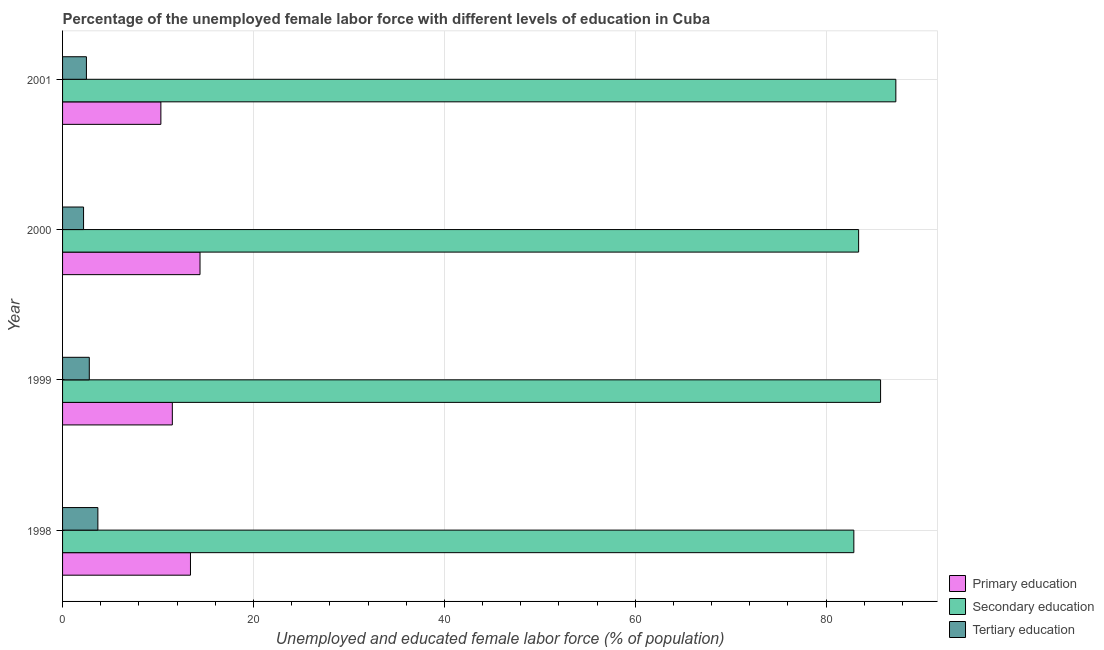How many different coloured bars are there?
Your answer should be very brief. 3. How many groups of bars are there?
Give a very brief answer. 4. How many bars are there on the 2nd tick from the top?
Make the answer very short. 3. In how many cases, is the number of bars for a given year not equal to the number of legend labels?
Your response must be concise. 0. What is the percentage of female labor force who received secondary education in 2001?
Your answer should be compact. 87.3. Across all years, what is the maximum percentage of female labor force who received tertiary education?
Offer a very short reply. 3.7. Across all years, what is the minimum percentage of female labor force who received primary education?
Offer a terse response. 10.3. In which year was the percentage of female labor force who received primary education maximum?
Make the answer very short. 2000. What is the total percentage of female labor force who received secondary education in the graph?
Your answer should be compact. 339.3. What is the difference between the percentage of female labor force who received secondary education in 1998 and that in 2001?
Provide a short and direct response. -4.4. What is the difference between the percentage of female labor force who received primary education in 2001 and the percentage of female labor force who received tertiary education in 1998?
Offer a very short reply. 6.6. In the year 1999, what is the difference between the percentage of female labor force who received tertiary education and percentage of female labor force who received primary education?
Give a very brief answer. -8.7. Is the percentage of female labor force who received tertiary education in 1998 less than that in 2001?
Keep it short and to the point. No. In how many years, is the percentage of female labor force who received secondary education greater than the average percentage of female labor force who received secondary education taken over all years?
Keep it short and to the point. 2. What does the 2nd bar from the top in 2001 represents?
Provide a short and direct response. Secondary education. What does the 3rd bar from the bottom in 2001 represents?
Provide a succinct answer. Tertiary education. Is it the case that in every year, the sum of the percentage of female labor force who received primary education and percentage of female labor force who received secondary education is greater than the percentage of female labor force who received tertiary education?
Your response must be concise. Yes. Are the values on the major ticks of X-axis written in scientific E-notation?
Offer a terse response. No. Does the graph contain grids?
Provide a short and direct response. Yes. Where does the legend appear in the graph?
Give a very brief answer. Bottom right. How are the legend labels stacked?
Your answer should be very brief. Vertical. What is the title of the graph?
Keep it short and to the point. Percentage of the unemployed female labor force with different levels of education in Cuba. What is the label or title of the X-axis?
Offer a very short reply. Unemployed and educated female labor force (% of population). What is the label or title of the Y-axis?
Provide a short and direct response. Year. What is the Unemployed and educated female labor force (% of population) in Primary education in 1998?
Offer a terse response. 13.4. What is the Unemployed and educated female labor force (% of population) in Secondary education in 1998?
Provide a short and direct response. 82.9. What is the Unemployed and educated female labor force (% of population) of Tertiary education in 1998?
Your answer should be compact. 3.7. What is the Unemployed and educated female labor force (% of population) of Secondary education in 1999?
Offer a very short reply. 85.7. What is the Unemployed and educated female labor force (% of population) of Tertiary education in 1999?
Offer a terse response. 2.8. What is the Unemployed and educated female labor force (% of population) in Primary education in 2000?
Your answer should be compact. 14.4. What is the Unemployed and educated female labor force (% of population) of Secondary education in 2000?
Ensure brevity in your answer.  83.4. What is the Unemployed and educated female labor force (% of population) in Tertiary education in 2000?
Make the answer very short. 2.2. What is the Unemployed and educated female labor force (% of population) in Primary education in 2001?
Provide a short and direct response. 10.3. What is the Unemployed and educated female labor force (% of population) of Secondary education in 2001?
Offer a terse response. 87.3. What is the Unemployed and educated female labor force (% of population) in Tertiary education in 2001?
Keep it short and to the point. 2.5. Across all years, what is the maximum Unemployed and educated female labor force (% of population) of Primary education?
Your response must be concise. 14.4. Across all years, what is the maximum Unemployed and educated female labor force (% of population) in Secondary education?
Give a very brief answer. 87.3. Across all years, what is the maximum Unemployed and educated female labor force (% of population) of Tertiary education?
Make the answer very short. 3.7. Across all years, what is the minimum Unemployed and educated female labor force (% of population) of Primary education?
Provide a succinct answer. 10.3. Across all years, what is the minimum Unemployed and educated female labor force (% of population) of Secondary education?
Offer a terse response. 82.9. Across all years, what is the minimum Unemployed and educated female labor force (% of population) in Tertiary education?
Keep it short and to the point. 2.2. What is the total Unemployed and educated female labor force (% of population) of Primary education in the graph?
Your response must be concise. 49.6. What is the total Unemployed and educated female labor force (% of population) in Secondary education in the graph?
Provide a short and direct response. 339.3. What is the total Unemployed and educated female labor force (% of population) in Tertiary education in the graph?
Provide a succinct answer. 11.2. What is the difference between the Unemployed and educated female labor force (% of population) in Tertiary education in 1998 and that in 1999?
Give a very brief answer. 0.9. What is the difference between the Unemployed and educated female labor force (% of population) of Primary education in 1998 and that in 2000?
Provide a short and direct response. -1. What is the difference between the Unemployed and educated female labor force (% of population) in Secondary education in 1998 and that in 2000?
Provide a short and direct response. -0.5. What is the difference between the Unemployed and educated female labor force (% of population) in Tertiary education in 1998 and that in 2000?
Offer a terse response. 1.5. What is the difference between the Unemployed and educated female labor force (% of population) in Secondary education in 1998 and that in 2001?
Your answer should be compact. -4.4. What is the difference between the Unemployed and educated female labor force (% of population) of Secondary education in 1999 and that in 2000?
Your answer should be very brief. 2.3. What is the difference between the Unemployed and educated female labor force (% of population) of Tertiary education in 1999 and that in 2000?
Offer a terse response. 0.6. What is the difference between the Unemployed and educated female labor force (% of population) in Secondary education in 1999 and that in 2001?
Provide a short and direct response. -1.6. What is the difference between the Unemployed and educated female labor force (% of population) in Primary education in 2000 and that in 2001?
Your response must be concise. 4.1. What is the difference between the Unemployed and educated female labor force (% of population) of Tertiary education in 2000 and that in 2001?
Your response must be concise. -0.3. What is the difference between the Unemployed and educated female labor force (% of population) in Primary education in 1998 and the Unemployed and educated female labor force (% of population) in Secondary education in 1999?
Offer a very short reply. -72.3. What is the difference between the Unemployed and educated female labor force (% of population) of Secondary education in 1998 and the Unemployed and educated female labor force (% of population) of Tertiary education in 1999?
Make the answer very short. 80.1. What is the difference between the Unemployed and educated female labor force (% of population) of Primary education in 1998 and the Unemployed and educated female labor force (% of population) of Secondary education in 2000?
Your response must be concise. -70. What is the difference between the Unemployed and educated female labor force (% of population) of Secondary education in 1998 and the Unemployed and educated female labor force (% of population) of Tertiary education in 2000?
Provide a short and direct response. 80.7. What is the difference between the Unemployed and educated female labor force (% of population) of Primary education in 1998 and the Unemployed and educated female labor force (% of population) of Secondary education in 2001?
Your response must be concise. -73.9. What is the difference between the Unemployed and educated female labor force (% of population) of Secondary education in 1998 and the Unemployed and educated female labor force (% of population) of Tertiary education in 2001?
Your answer should be very brief. 80.4. What is the difference between the Unemployed and educated female labor force (% of population) of Primary education in 1999 and the Unemployed and educated female labor force (% of population) of Secondary education in 2000?
Ensure brevity in your answer.  -71.9. What is the difference between the Unemployed and educated female labor force (% of population) of Primary education in 1999 and the Unemployed and educated female labor force (% of population) of Tertiary education in 2000?
Your answer should be compact. 9.3. What is the difference between the Unemployed and educated female labor force (% of population) of Secondary education in 1999 and the Unemployed and educated female labor force (% of population) of Tertiary education in 2000?
Your answer should be very brief. 83.5. What is the difference between the Unemployed and educated female labor force (% of population) of Primary education in 1999 and the Unemployed and educated female labor force (% of population) of Secondary education in 2001?
Keep it short and to the point. -75.8. What is the difference between the Unemployed and educated female labor force (% of population) of Primary education in 1999 and the Unemployed and educated female labor force (% of population) of Tertiary education in 2001?
Your answer should be compact. 9. What is the difference between the Unemployed and educated female labor force (% of population) of Secondary education in 1999 and the Unemployed and educated female labor force (% of population) of Tertiary education in 2001?
Your response must be concise. 83.2. What is the difference between the Unemployed and educated female labor force (% of population) of Primary education in 2000 and the Unemployed and educated female labor force (% of population) of Secondary education in 2001?
Provide a succinct answer. -72.9. What is the difference between the Unemployed and educated female labor force (% of population) of Secondary education in 2000 and the Unemployed and educated female labor force (% of population) of Tertiary education in 2001?
Offer a very short reply. 80.9. What is the average Unemployed and educated female labor force (% of population) in Primary education per year?
Offer a very short reply. 12.4. What is the average Unemployed and educated female labor force (% of population) of Secondary education per year?
Give a very brief answer. 84.83. In the year 1998, what is the difference between the Unemployed and educated female labor force (% of population) of Primary education and Unemployed and educated female labor force (% of population) of Secondary education?
Make the answer very short. -69.5. In the year 1998, what is the difference between the Unemployed and educated female labor force (% of population) of Primary education and Unemployed and educated female labor force (% of population) of Tertiary education?
Your response must be concise. 9.7. In the year 1998, what is the difference between the Unemployed and educated female labor force (% of population) of Secondary education and Unemployed and educated female labor force (% of population) of Tertiary education?
Give a very brief answer. 79.2. In the year 1999, what is the difference between the Unemployed and educated female labor force (% of population) in Primary education and Unemployed and educated female labor force (% of population) in Secondary education?
Offer a terse response. -74.2. In the year 1999, what is the difference between the Unemployed and educated female labor force (% of population) of Secondary education and Unemployed and educated female labor force (% of population) of Tertiary education?
Ensure brevity in your answer.  82.9. In the year 2000, what is the difference between the Unemployed and educated female labor force (% of population) of Primary education and Unemployed and educated female labor force (% of population) of Secondary education?
Ensure brevity in your answer.  -69. In the year 2000, what is the difference between the Unemployed and educated female labor force (% of population) of Secondary education and Unemployed and educated female labor force (% of population) of Tertiary education?
Offer a terse response. 81.2. In the year 2001, what is the difference between the Unemployed and educated female labor force (% of population) in Primary education and Unemployed and educated female labor force (% of population) in Secondary education?
Offer a very short reply. -77. In the year 2001, what is the difference between the Unemployed and educated female labor force (% of population) of Secondary education and Unemployed and educated female labor force (% of population) of Tertiary education?
Offer a very short reply. 84.8. What is the ratio of the Unemployed and educated female labor force (% of population) of Primary education in 1998 to that in 1999?
Keep it short and to the point. 1.17. What is the ratio of the Unemployed and educated female labor force (% of population) of Secondary education in 1998 to that in 1999?
Keep it short and to the point. 0.97. What is the ratio of the Unemployed and educated female labor force (% of population) of Tertiary education in 1998 to that in 1999?
Your answer should be very brief. 1.32. What is the ratio of the Unemployed and educated female labor force (% of population) in Primary education in 1998 to that in 2000?
Ensure brevity in your answer.  0.93. What is the ratio of the Unemployed and educated female labor force (% of population) in Secondary education in 1998 to that in 2000?
Your response must be concise. 0.99. What is the ratio of the Unemployed and educated female labor force (% of population) in Tertiary education in 1998 to that in 2000?
Your answer should be compact. 1.68. What is the ratio of the Unemployed and educated female labor force (% of population) of Primary education in 1998 to that in 2001?
Provide a succinct answer. 1.3. What is the ratio of the Unemployed and educated female labor force (% of population) of Secondary education in 1998 to that in 2001?
Give a very brief answer. 0.95. What is the ratio of the Unemployed and educated female labor force (% of population) of Tertiary education in 1998 to that in 2001?
Provide a succinct answer. 1.48. What is the ratio of the Unemployed and educated female labor force (% of population) in Primary education in 1999 to that in 2000?
Provide a succinct answer. 0.8. What is the ratio of the Unemployed and educated female labor force (% of population) in Secondary education in 1999 to that in 2000?
Your answer should be very brief. 1.03. What is the ratio of the Unemployed and educated female labor force (% of population) in Tertiary education in 1999 to that in 2000?
Your answer should be very brief. 1.27. What is the ratio of the Unemployed and educated female labor force (% of population) of Primary education in 1999 to that in 2001?
Ensure brevity in your answer.  1.12. What is the ratio of the Unemployed and educated female labor force (% of population) of Secondary education in 1999 to that in 2001?
Make the answer very short. 0.98. What is the ratio of the Unemployed and educated female labor force (% of population) in Tertiary education in 1999 to that in 2001?
Offer a terse response. 1.12. What is the ratio of the Unemployed and educated female labor force (% of population) in Primary education in 2000 to that in 2001?
Your answer should be very brief. 1.4. What is the ratio of the Unemployed and educated female labor force (% of population) in Secondary education in 2000 to that in 2001?
Your answer should be very brief. 0.96. What is the ratio of the Unemployed and educated female labor force (% of population) of Tertiary education in 2000 to that in 2001?
Offer a terse response. 0.88. What is the difference between the highest and the second highest Unemployed and educated female labor force (% of population) in Secondary education?
Make the answer very short. 1.6. What is the difference between the highest and the lowest Unemployed and educated female labor force (% of population) of Primary education?
Keep it short and to the point. 4.1. 